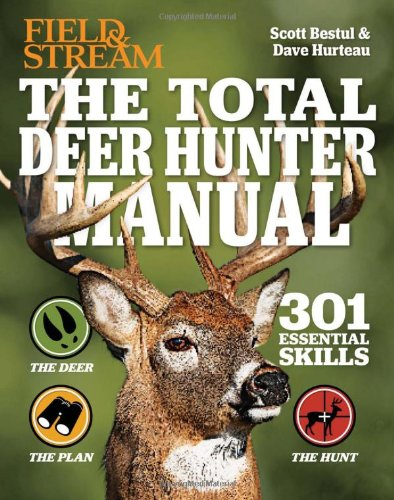Who is the author of this book? The book titled 'The Total Deer Hunter Manual' is authored by Scott Bestul along with Dave Hurteau, providing a comprehensive guide on deer hunting. 